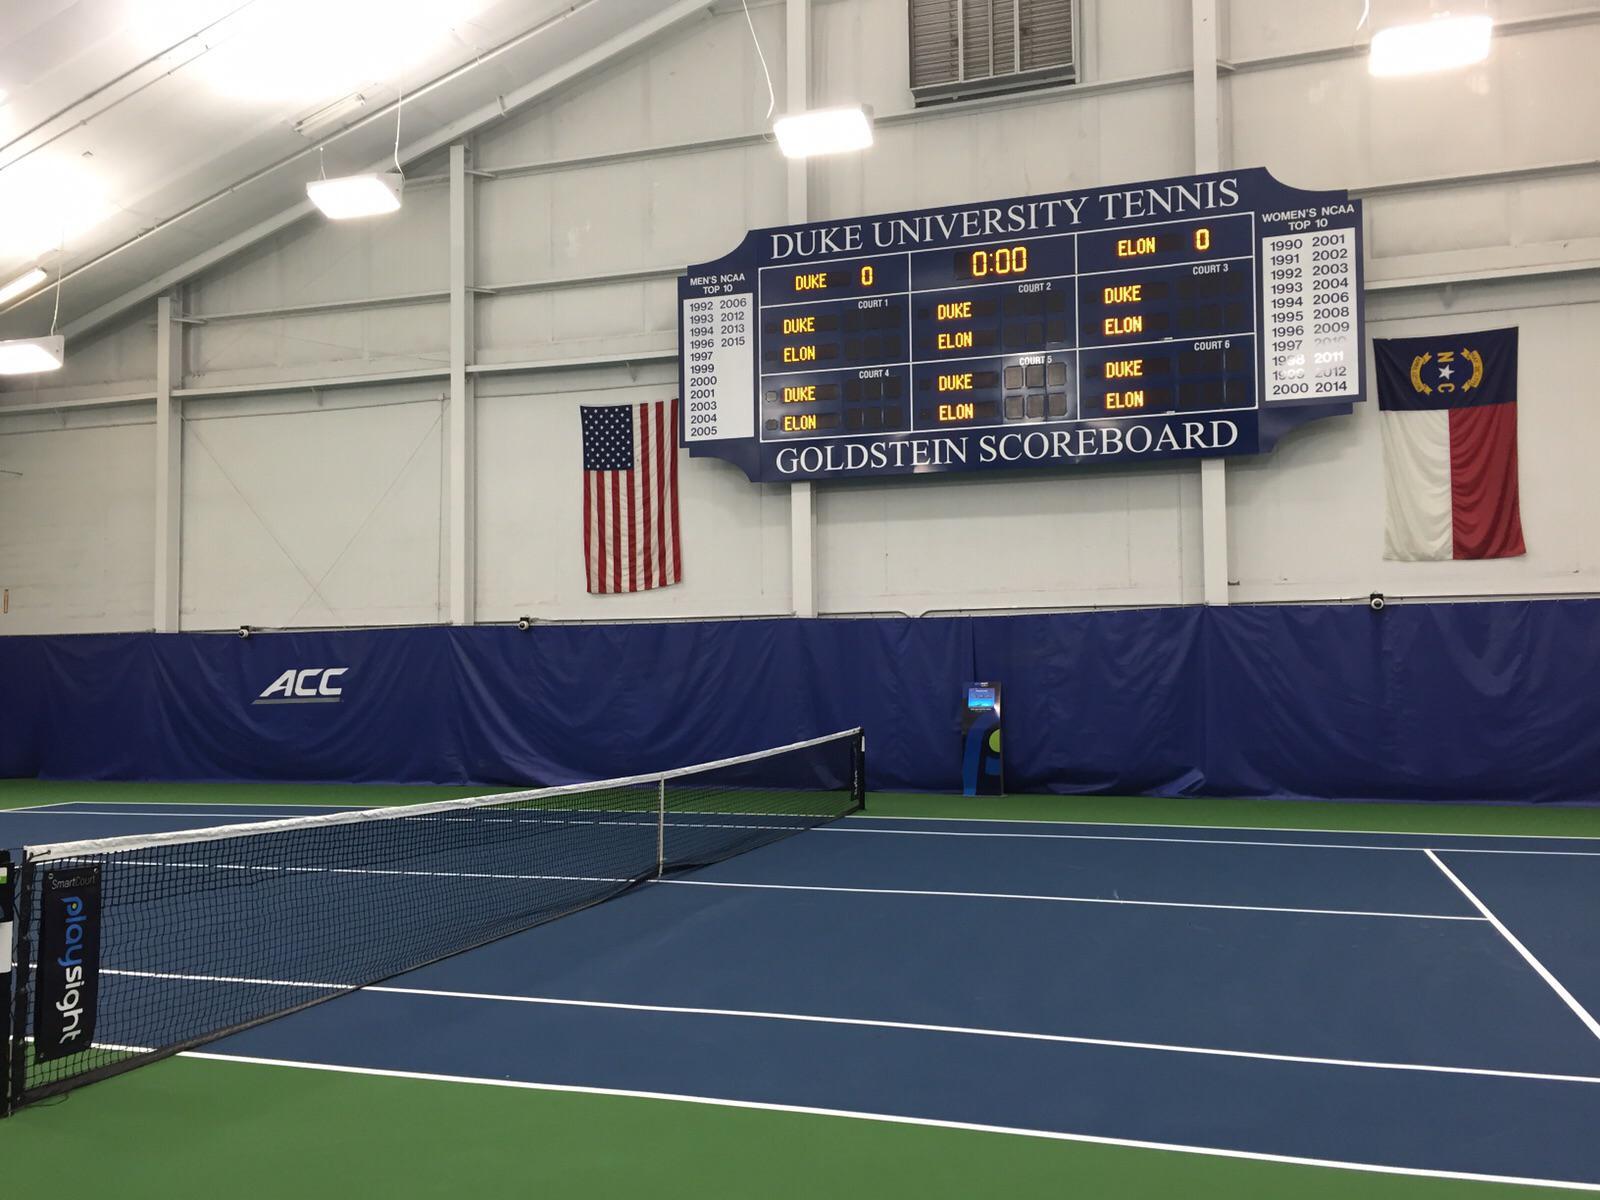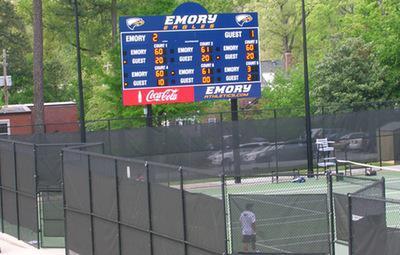The first image is the image on the left, the second image is the image on the right. Examine the images to the left and right. Is the description "The left image features a rectangular sign containing a screen that displays a sporting event." accurate? Answer yes or no. No. The first image is the image on the left, the second image is the image on the right. Considering the images on both sides, is "The sport being played in the left image was invented in the United States." valid? Answer yes or no. No. 